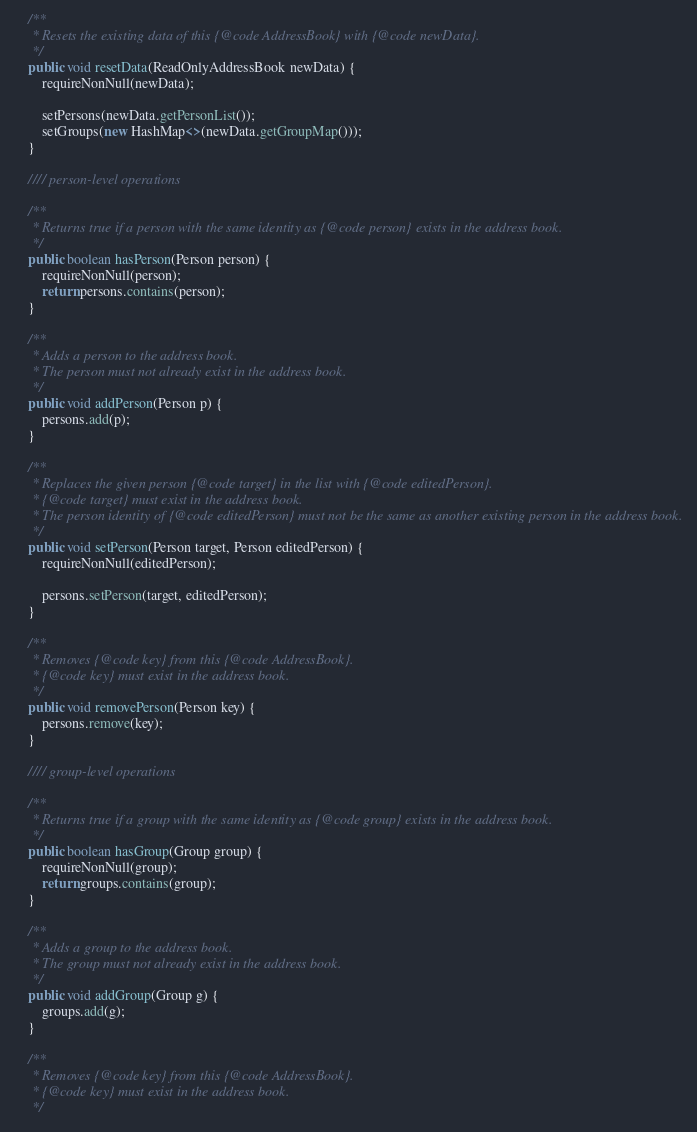Convert code to text. <code><loc_0><loc_0><loc_500><loc_500><_Java_>    /**
     * Resets the existing data of this {@code AddressBook} with {@code newData}.
     */
    public void resetData(ReadOnlyAddressBook newData) {
        requireNonNull(newData);

        setPersons(newData.getPersonList());
        setGroups(new HashMap<>(newData.getGroupMap()));
    }

    //// person-level operations

    /**
     * Returns true if a person with the same identity as {@code person} exists in the address book.
     */
    public boolean hasPerson(Person person) {
        requireNonNull(person);
        return persons.contains(person);
    }

    /**
     * Adds a person to the address book.
     * The person must not already exist in the address book.
     */
    public void addPerson(Person p) {
        persons.add(p);
    }

    /**
     * Replaces the given person {@code target} in the list with {@code editedPerson}.
     * {@code target} must exist in the address book.
     * The person identity of {@code editedPerson} must not be the same as another existing person in the address book.
     */
    public void setPerson(Person target, Person editedPerson) {
        requireNonNull(editedPerson);

        persons.setPerson(target, editedPerson);
    }

    /**
     * Removes {@code key} from this {@code AddressBook}.
     * {@code key} must exist in the address book.
     */
    public void removePerson(Person key) {
        persons.remove(key);
    }

    //// group-level operations

    /**
     * Returns true if a group with the same identity as {@code group} exists in the address book.
     */
    public boolean hasGroup(Group group) {
        requireNonNull(group);
        return groups.contains(group);
    }

    /**
     * Adds a group to the address book.
     * The group must not already exist in the address book.
     */
    public void addGroup(Group g) {
        groups.add(g);
    }

    /**
     * Removes {@code key} from this {@code AddressBook}.
     * {@code key} must exist in the address book.
     */</code> 